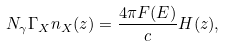Convert formula to latex. <formula><loc_0><loc_0><loc_500><loc_500>N _ { \gamma } \Gamma _ { X } n _ { X } ( z ) = \frac { 4 \pi F ( E ) } { c } H ( z ) ,</formula> 